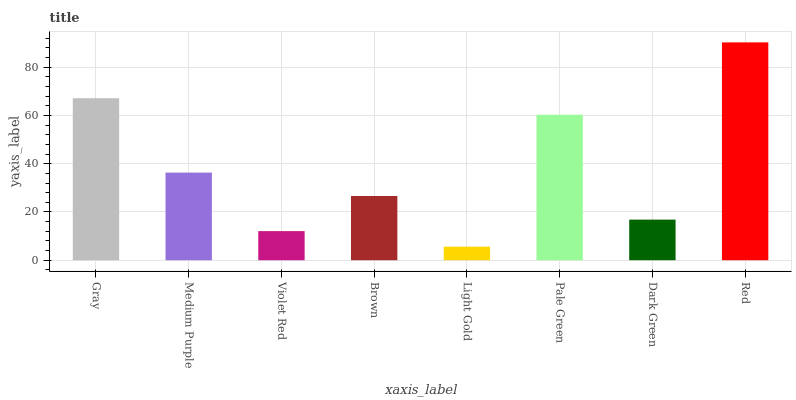Is Medium Purple the minimum?
Answer yes or no. No. Is Medium Purple the maximum?
Answer yes or no. No. Is Gray greater than Medium Purple?
Answer yes or no. Yes. Is Medium Purple less than Gray?
Answer yes or no. Yes. Is Medium Purple greater than Gray?
Answer yes or no. No. Is Gray less than Medium Purple?
Answer yes or no. No. Is Medium Purple the high median?
Answer yes or no. Yes. Is Brown the low median?
Answer yes or no. Yes. Is Violet Red the high median?
Answer yes or no. No. Is Medium Purple the low median?
Answer yes or no. No. 